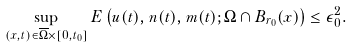Convert formula to latex. <formula><loc_0><loc_0><loc_500><loc_500>\sup _ { ( x , t ) \in \overline { \Omega } \times [ 0 , t _ { 0 } ] } E \left ( u ( t ) , { n } ( t ) , { m } ( t ) ; \Omega \cap B _ { r _ { 0 } } ( x ) \right ) \leq \epsilon _ { 0 } ^ { 2 } .</formula> 